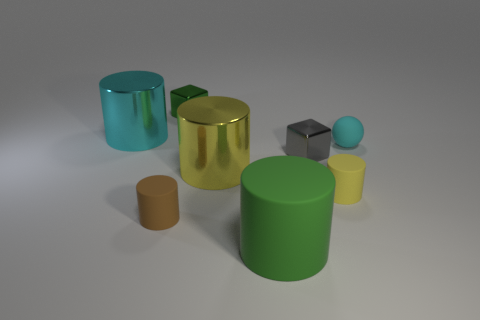Subtract 1 cylinders. How many cylinders are left? 4 Subtract all brown cylinders. How many cylinders are left? 4 Subtract all big green rubber cylinders. How many cylinders are left? 4 Add 1 blue cylinders. How many objects exist? 9 Subtract all red cylinders. Subtract all gray blocks. How many cylinders are left? 5 Subtract all balls. How many objects are left? 7 Add 6 tiny red rubber cubes. How many tiny red rubber cubes exist? 6 Subtract 0 blue cylinders. How many objects are left? 8 Subtract all large cyan metallic blocks. Subtract all cyan matte things. How many objects are left? 7 Add 4 big things. How many big things are left? 7 